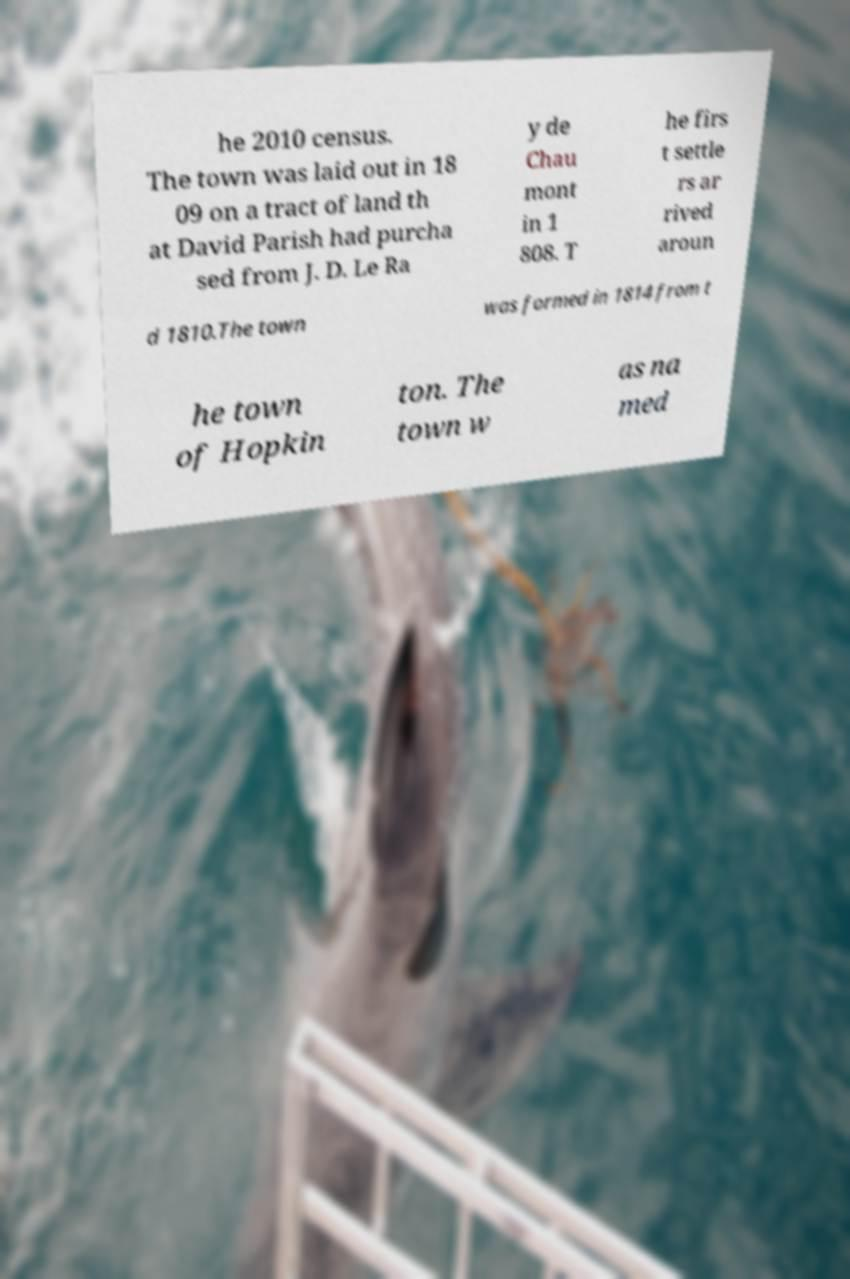Could you extract and type out the text from this image? he 2010 census. The town was laid out in 18 09 on a tract of land th at David Parish had purcha sed from J. D. Le Ra y de Chau mont in 1 808. T he firs t settle rs ar rived aroun d 1810.The town was formed in 1814 from t he town of Hopkin ton. The town w as na med 